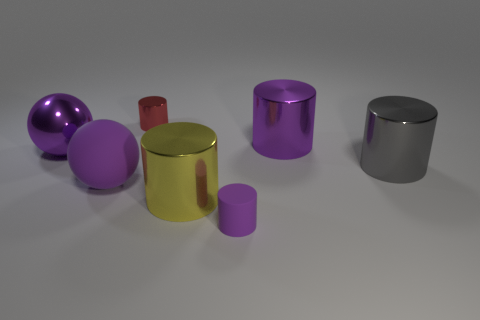Subtract 2 cylinders. How many cylinders are left? 3 Subtract all yellow cylinders. How many cylinders are left? 4 Subtract all red cylinders. How many cylinders are left? 4 Subtract all blue cylinders. Subtract all yellow spheres. How many cylinders are left? 5 Add 1 spheres. How many objects exist? 8 Subtract all balls. How many objects are left? 5 Subtract 0 gray cubes. How many objects are left? 7 Subtract all purple rubber spheres. Subtract all large gray metallic cylinders. How many objects are left? 5 Add 5 big objects. How many big objects are left? 10 Add 2 tiny cyan objects. How many tiny cyan objects exist? 2 